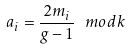Convert formula to latex. <formula><loc_0><loc_0><loc_500><loc_500>a _ { i } = \frac { 2 m _ { i } } { g - 1 } \text { } m o d k</formula> 